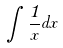Convert formula to latex. <formula><loc_0><loc_0><loc_500><loc_500>\int \frac { 1 } { x } d x</formula> 